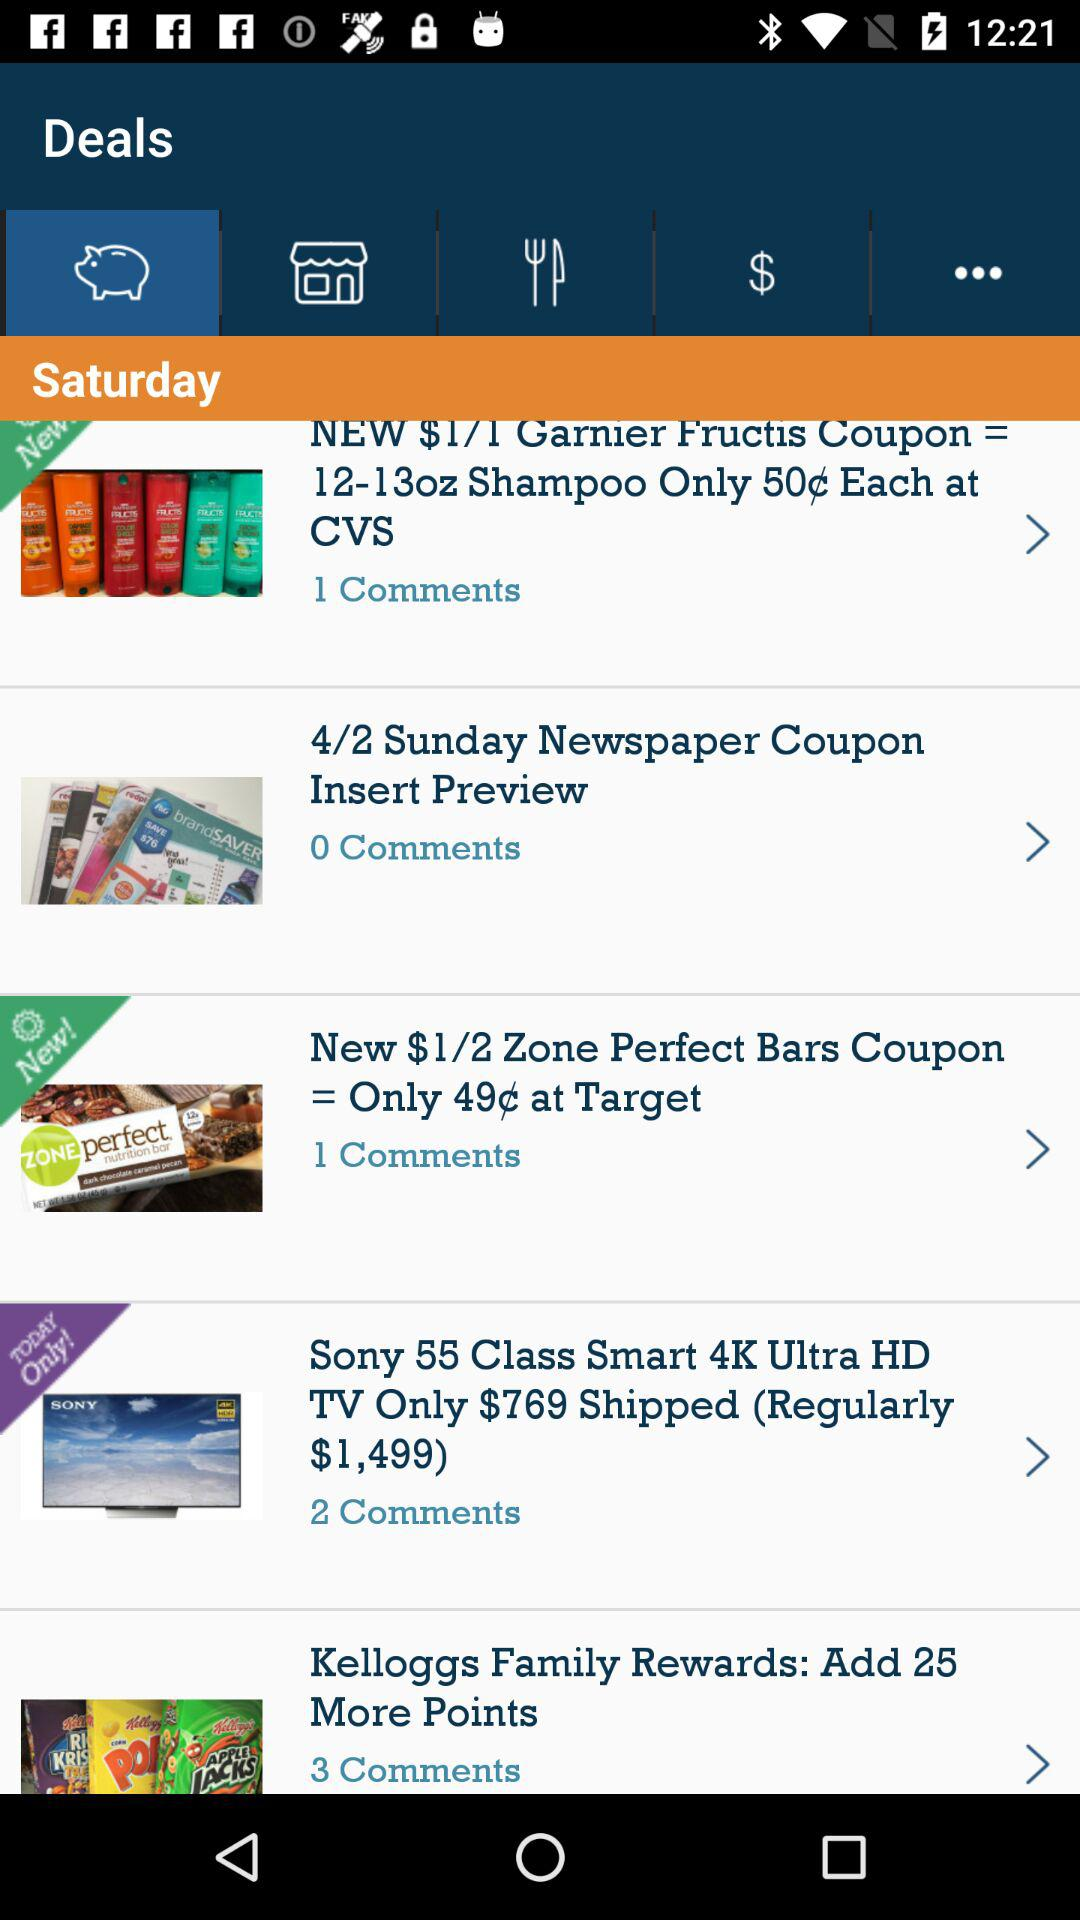Which tab has been selected? The tab "Deals" has been selected. 